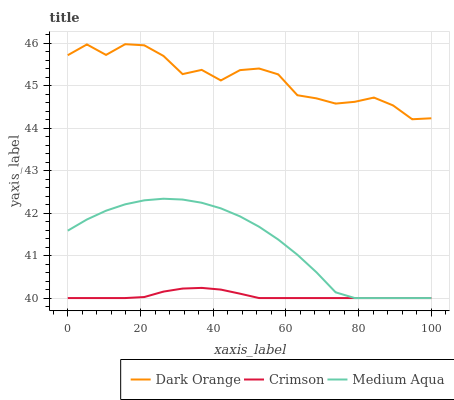Does Crimson have the minimum area under the curve?
Answer yes or no. Yes. Does Dark Orange have the maximum area under the curve?
Answer yes or no. Yes. Does Medium Aqua have the minimum area under the curve?
Answer yes or no. No. Does Medium Aqua have the maximum area under the curve?
Answer yes or no. No. Is Crimson the smoothest?
Answer yes or no. Yes. Is Dark Orange the roughest?
Answer yes or no. Yes. Is Medium Aqua the smoothest?
Answer yes or no. No. Is Medium Aqua the roughest?
Answer yes or no. No. Does Crimson have the lowest value?
Answer yes or no. Yes. Does Dark Orange have the lowest value?
Answer yes or no. No. Does Dark Orange have the highest value?
Answer yes or no. Yes. Does Medium Aqua have the highest value?
Answer yes or no. No. Is Medium Aqua less than Dark Orange?
Answer yes or no. Yes. Is Dark Orange greater than Crimson?
Answer yes or no. Yes. Does Medium Aqua intersect Crimson?
Answer yes or no. Yes. Is Medium Aqua less than Crimson?
Answer yes or no. No. Is Medium Aqua greater than Crimson?
Answer yes or no. No. Does Medium Aqua intersect Dark Orange?
Answer yes or no. No. 